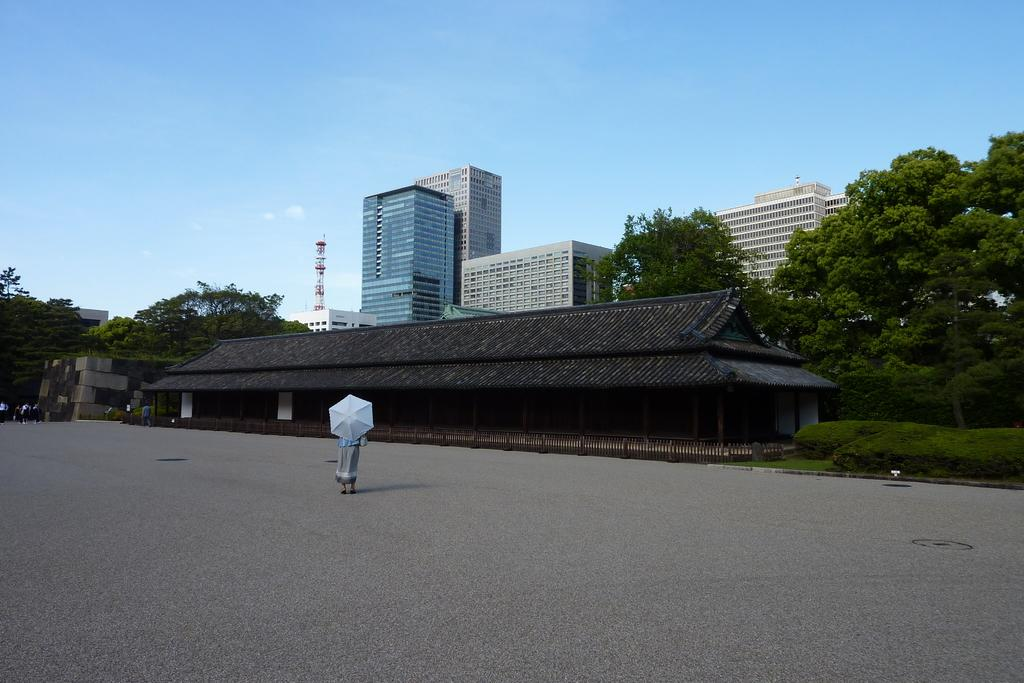What type of structures can be seen in the image? There are buildings and houses in the image. What else can be seen in the image besides structures? There are trees and people in the image. What are the people in the image doing? People are walking in the image, and one person is holding an umbrella and walking. What type of cub is playing with silk in the image? There is no cub or silk present in the image. What type of education is being taught in the image? There is no educational activity depicted in the image. 